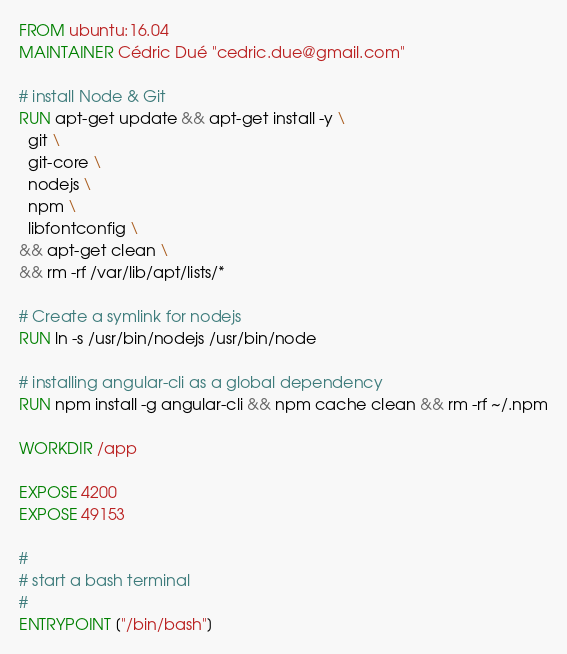Convert code to text. <code><loc_0><loc_0><loc_500><loc_500><_Dockerfile_>FROM ubuntu:16.04
MAINTAINER Cédric Dué "cedric.due@gmail.com"

# install Node & Git
RUN apt-get update && apt-get install -y \
  git \
  git-core \
  nodejs \
  npm \
  libfontconfig \
&& apt-get clean \
&& rm -rf /var/lib/apt/lists/*

# Create a symlink for nodejs
RUN ln -s /usr/bin/nodejs /usr/bin/node

# installing angular-cli as a global dependency
RUN npm install -g angular-cli && npm cache clean && rm -rf ~/.npm

WORKDIR /app

EXPOSE 4200
EXPOSE 49153

#
# start a bash terminal
#
ENTRYPOINT ["/bin/bash"]
</code> 